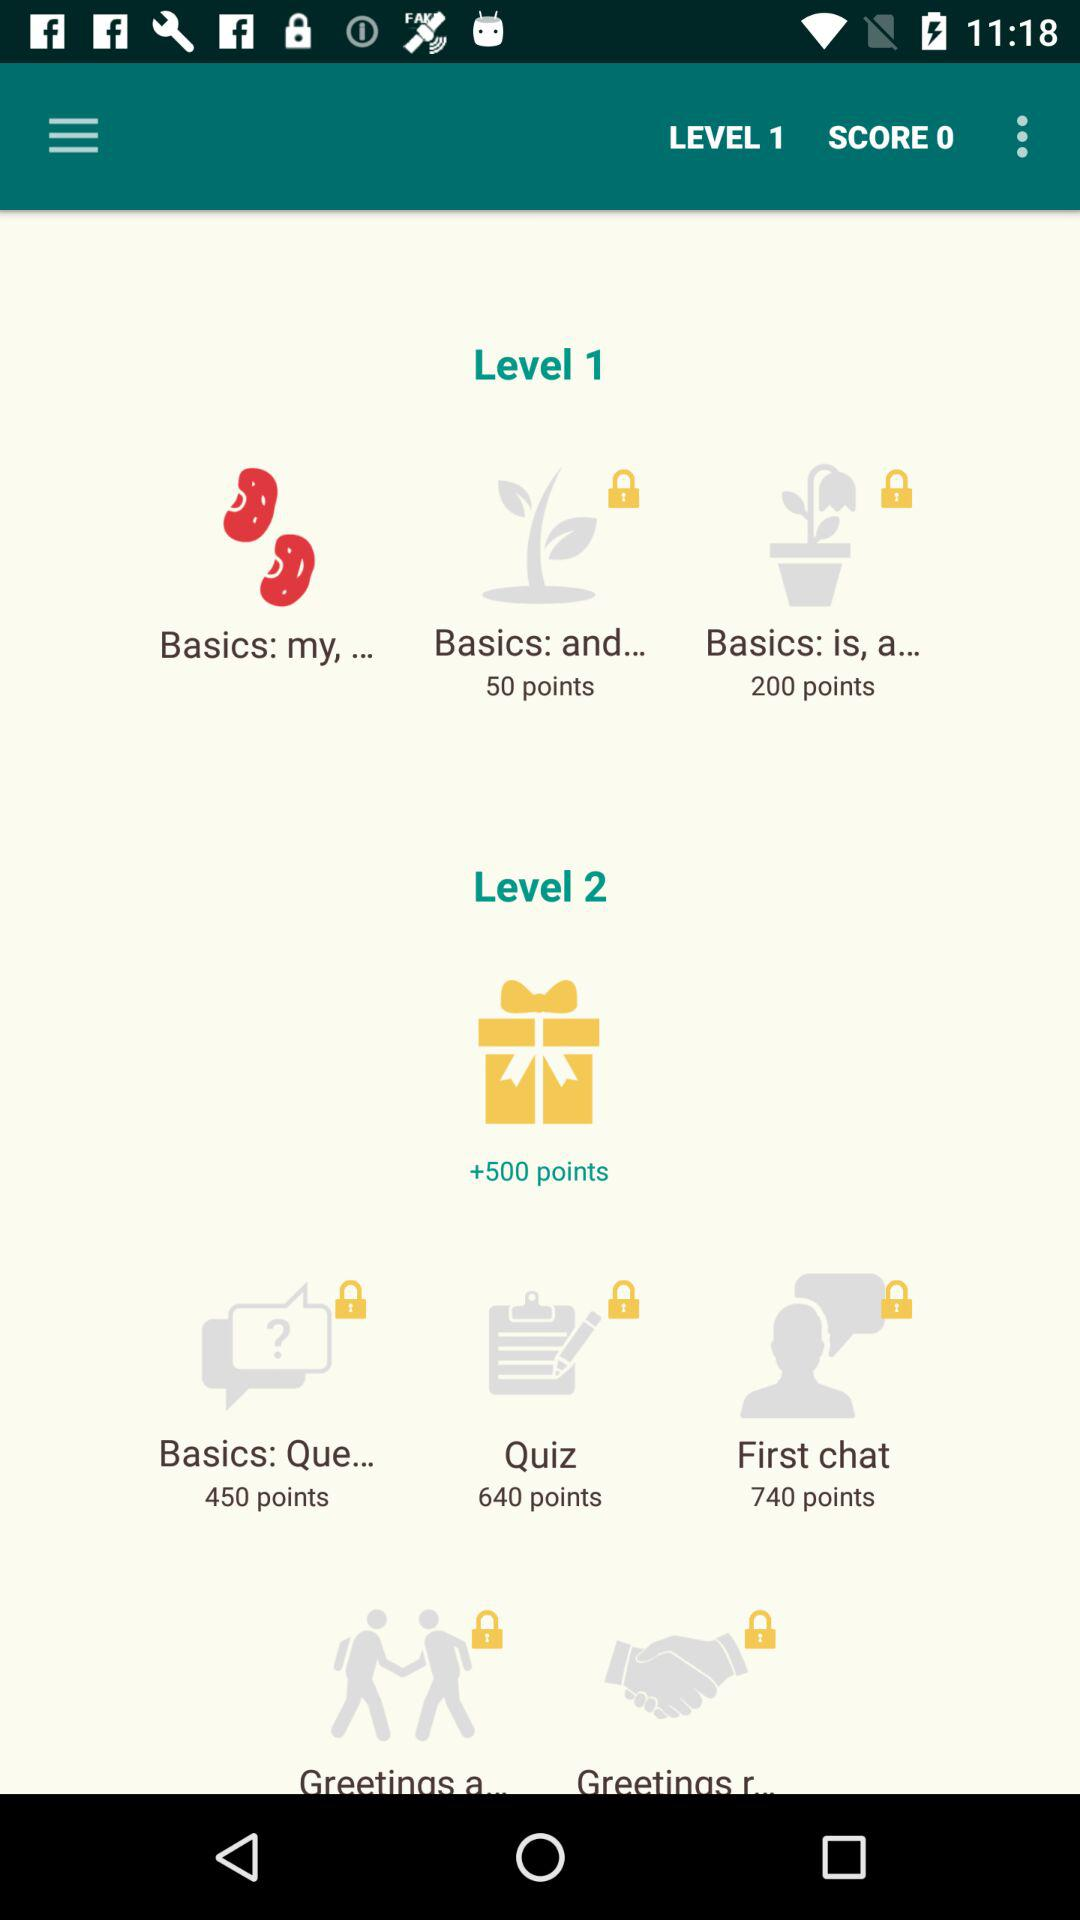What are the two levels being shown? The two levels being shown are Level 1 and Level 2. 